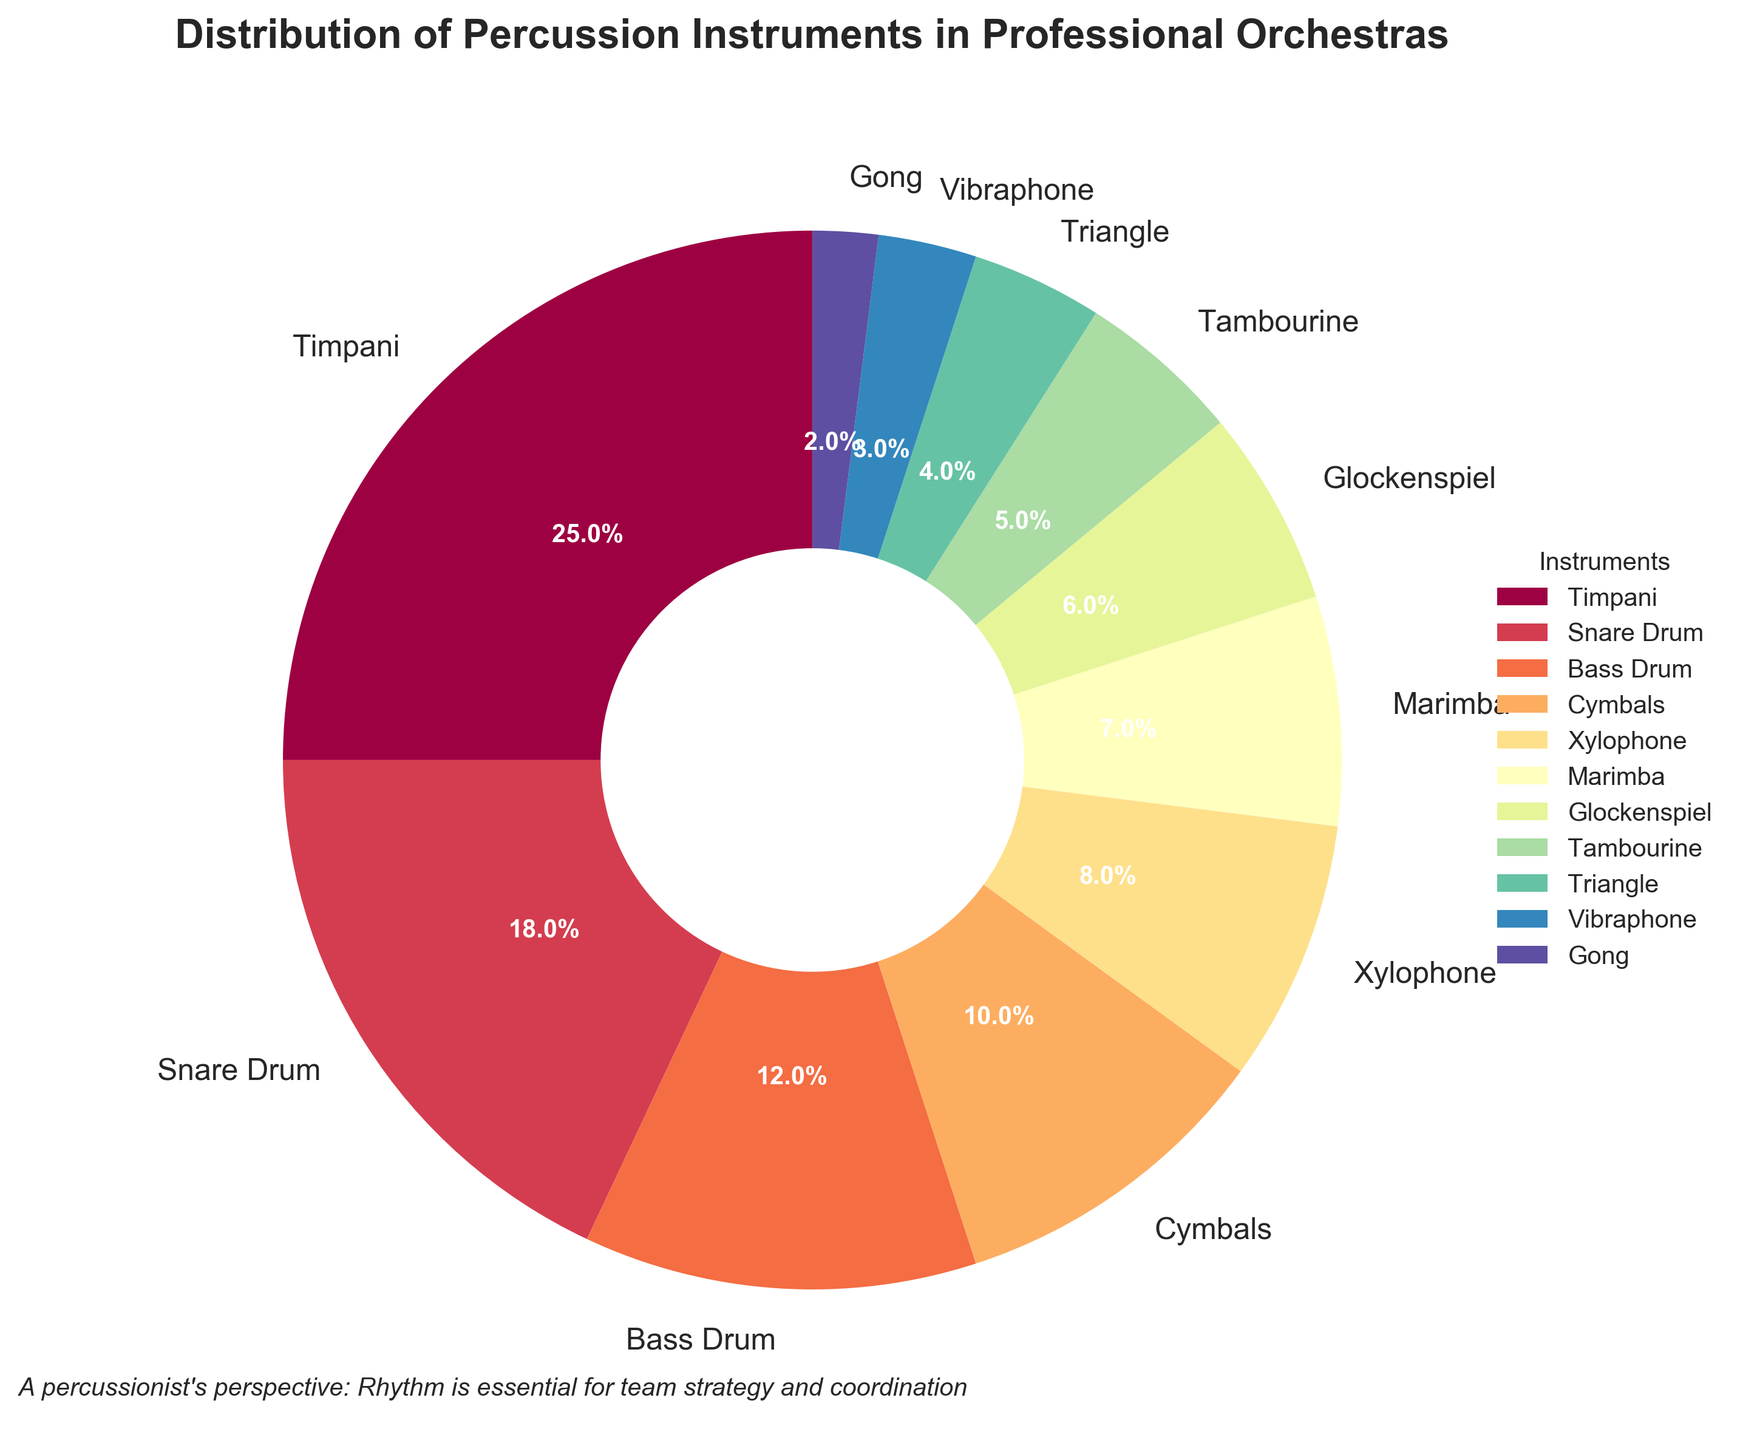Which instrument occupies the largest portion of the pie chart? The instrument with the largest percentage or the biggest slice in the chart can be identified directly. The Timpani occupies the maximum space on the chart with 25% of the distribution.
Answer: Timpani Which instruments together form approximately half of the total distribution? Adding the percentages of the top few instruments until the sum is about 50%. Timpani (25%) + Snare Drum (18%) + Bass Drum (12%) = 55%, slightly more than half.
Answer: Timpani, Snare Drum, Bass Drum What is the combined percentage of Glockenspiel, Tambourine, and Triangle? Sum the percentages of Glockenspiel (6%), Tambourine (5%), and Triangle (4%). 6% + 5% + 4% = 15%
Answer: 15% Which instrument has a larger percentage share, Marimba or Xylophone? Compare the percentages listed for Marimba (7%) and Xylophone (8%). Xylophone has a larger share.
Answer: Xylophone Which instruments have a share of less than 5%? Identify and list the instruments with percentages less than 5%. Triangle (4%), Vibraphone (3%), and Gong (2%) all have shares less than 5%.
Answer: Triangle, Vibraphone, Gong What's the difference in percentage between Cymbals and Bass Drum? Subtract the percentage of Bass Drum (12%) from Cymbals (10%). 12% - 10% = 2%
Answer: 2% How many instruments have a percentage share of 10% or more? Count the number of instruments with percentage shares of 10% or more. Timpani (25%), Snare Drum (18%), Bass Drum (12%), and Cymbals (10%) give us four instruments.
Answer: Four If you exclude Timpani, what percentage of the total is shared by the other instruments? Exclude Timpani (25%) from the total (100%). 100% - 25% = 75%
Answer: 75% Which section of the pie chart is colored lavishly and is centrally located within the legend? Observing the color spectrum used and wedge size, the Timpani section is likely the most vibrant and centrally important, associated with the first-listed color in the legend.
Answer: Timpani If you combine the least contributing instruments into one category, what will be their total percentage? Add up the smaller percentages: Gong (2%) and Vibraphone (3%) = 5%. Even adding Triangle (4%) still keeps them below others. Therefore, summing these smallest is 2% + 3% + 4% = 9%.
Answer: 9% 